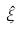<formula> <loc_0><loc_0><loc_500><loc_500>\hat { \xi }</formula> 